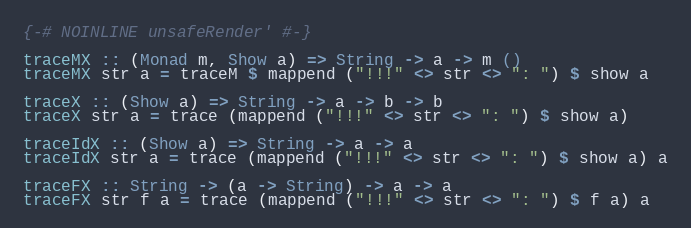<code> <loc_0><loc_0><loc_500><loc_500><_Haskell_>{-# NOINLINE unsafeRender' #-}

traceMX :: (Monad m, Show a) => String -> a -> m ()
traceMX str a = traceM $ mappend ("!!!" <> str <> ": ") $ show a

traceX :: (Show a) => String -> a -> b -> b
traceX str a = trace (mappend ("!!!" <> str <> ": ") $ show a)

traceIdX :: (Show a) => String -> a -> a
traceIdX str a = trace (mappend ("!!!" <> str <> ": ") $ show a) a

traceFX :: String -> (a -> String) -> a -> a
traceFX str f a = trace (mappend ("!!!" <> str <> ": ") $ f a) a

</code> 